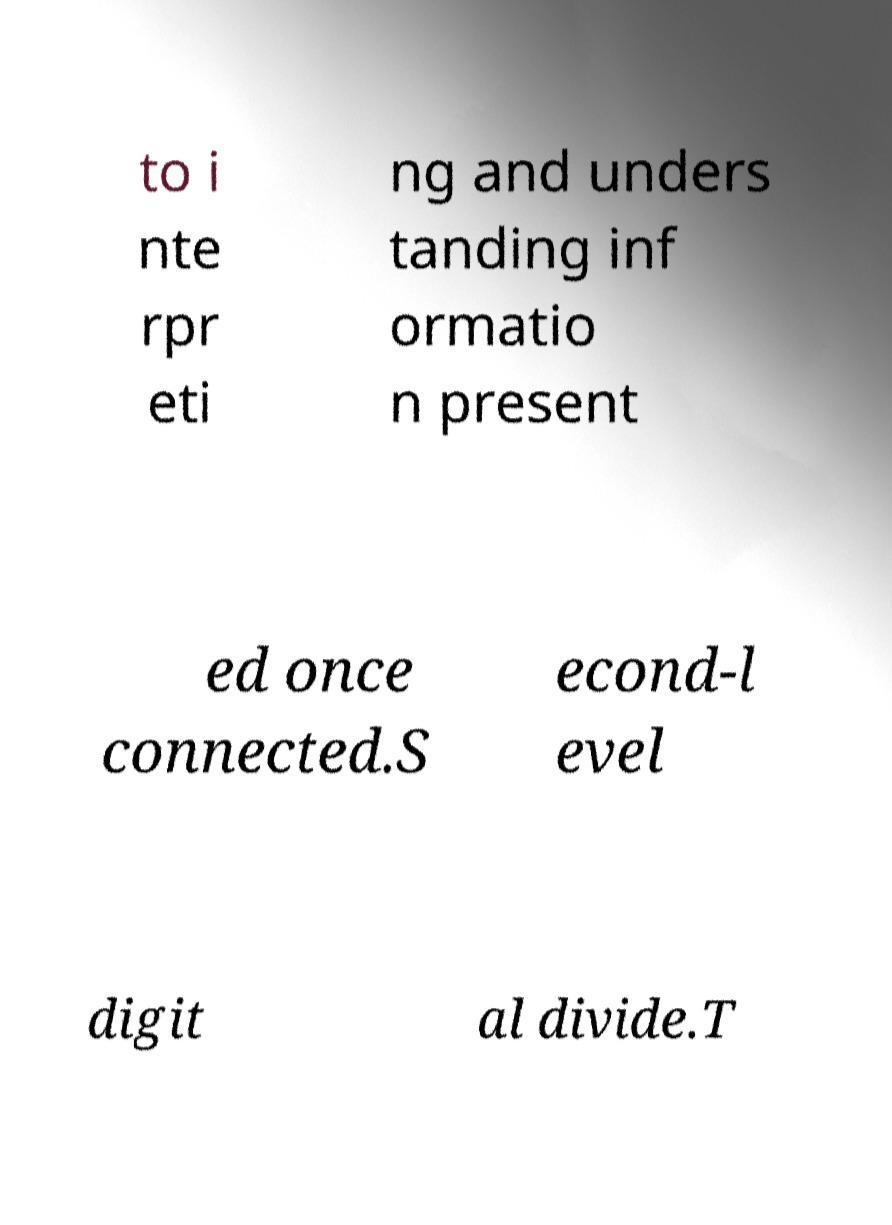There's text embedded in this image that I need extracted. Can you transcribe it verbatim? to i nte rpr eti ng and unders tanding inf ormatio n present ed once connected.S econd-l evel digit al divide.T 